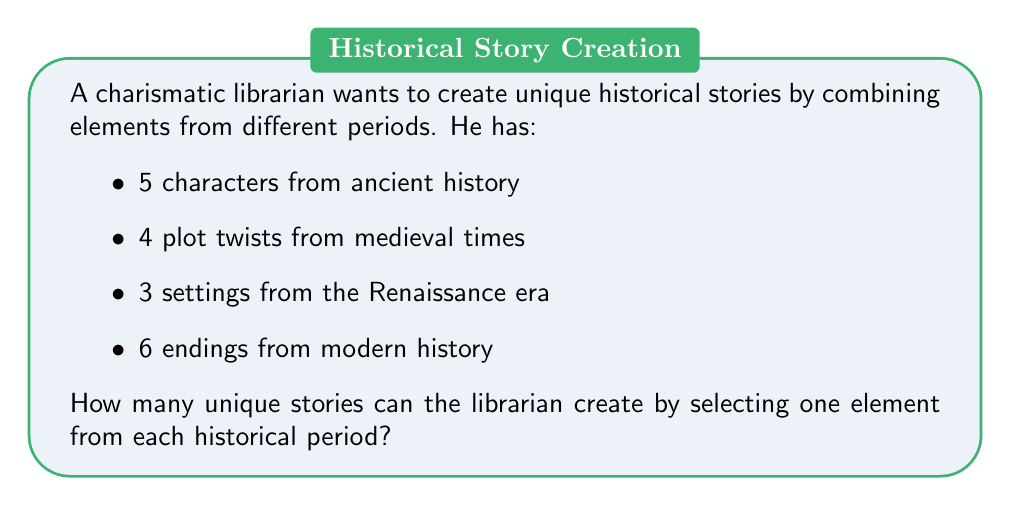Show me your answer to this math problem. To solve this problem, we'll use the Multiplication Principle of Counting. This principle states that if we have a sequence of independent choices, the total number of ways to make these choices is the product of the number of ways to make each individual choice.

Let's break it down step-by-step:

1. Characters from ancient history: There are 5 choices.
2. Plot twists from medieval times: There are 4 choices.
3. Settings from the Renaissance era: There are 3 choices.
4. Endings from modern history: There are 6 choices.

For each story, the librarian must choose one element from each category. The choices for each category are independent of the others.

Therefore, the total number of unique stories is:

$$5 \times 4 \times 3 \times 6$$

We can calculate this:

$$5 \times 4 \times 3 \times 6 = 20 \times 3 \times 6 = 60 \times 6 = 360$$

Thus, the librarian can create 360 unique stories by combining these elements from different historical periods.
Answer: 360 